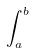Convert formula to latex. <formula><loc_0><loc_0><loc_500><loc_500>\int _ { a } ^ { b }</formula> 